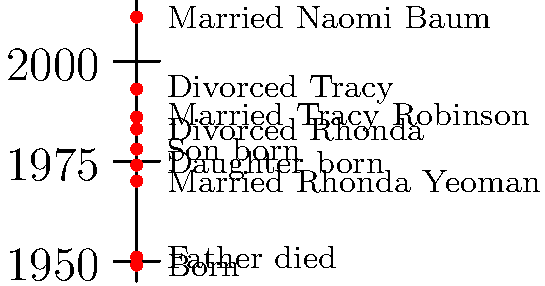Based on the timeline of Tony Danza's personal life milestones, how many years passed between his first marriage and his second marriage? To find the number of years between Tony Danza's first and second marriages, we need to follow these steps:

1. Identify the year of Tony Danza's first marriage:
   From the timeline, we can see that Tony Danza married Rhonda Yeoman in 1970.

2. Identify the year of Tony Danza's second marriage:
   The timeline shows that Tony Danza married Tracy Robinson in 1986.

3. Calculate the difference between these two years:
   $1986 - 1970 = 16$ years

Therefore, 16 years passed between Tony Danza's first marriage and his second marriage.
Answer: 16 years 